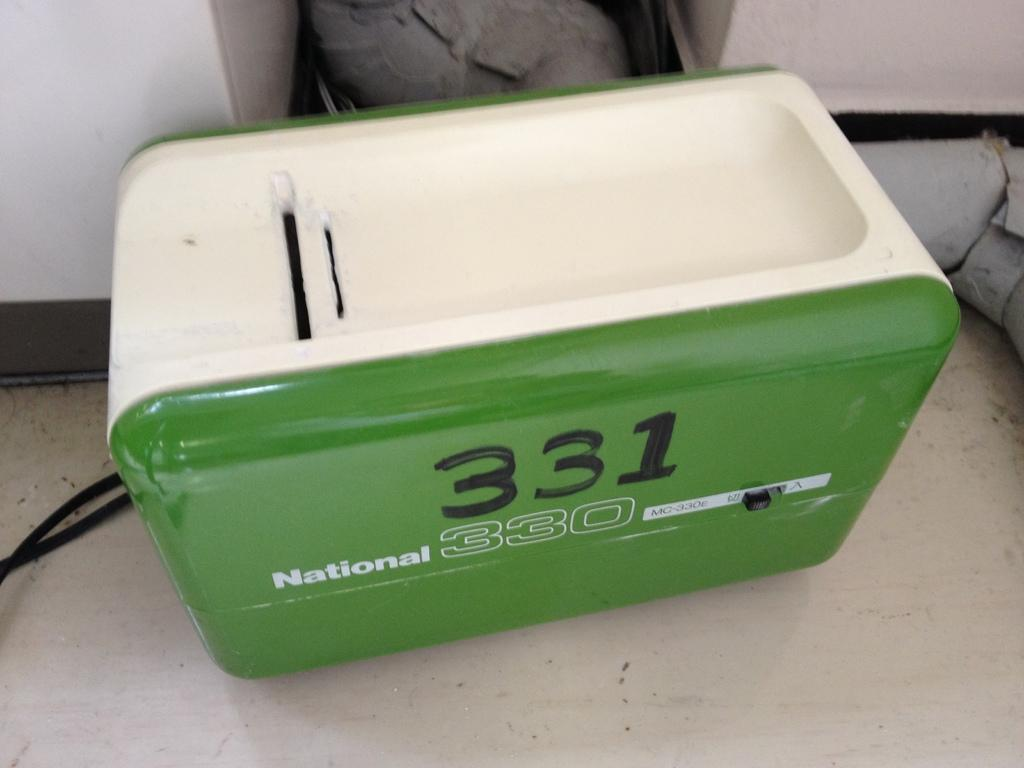What is the main object in the image? There is a machine in the image. What can be seen on the machine? There is writing on the machine. What else is present in the image besides the machine? There are wires in the image. What can be seen in the background of the image? There is a wall in the background of the image. Can you tell me how many yaks are standing next to the machine in the image? There are no yaks present in the image. What type of cork is being used to hold the writing on the machine in place? There is no cork visible in the image, and the writing is not being held in place by any cork. 